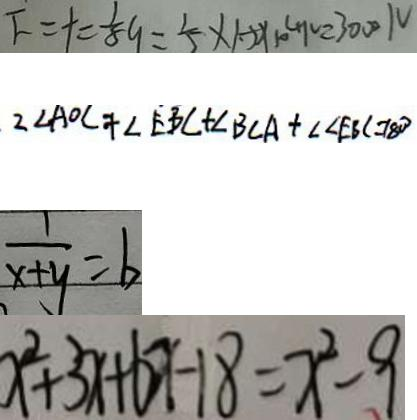Convert formula to latex. <formula><loc_0><loc_0><loc_500><loc_500>F = t = \frac { 1 } { 8 } 9 = \frac { 1 } { 5 } \times 1 . 2 2 \times 1 0 ^ { 4 } N = 3 0 0 N 
 2 \angle A O C + \angle E B C + \angle B C A + \angle \angle E B C = 1 8 0 ^ { \circ } 
 \frac { 1 } { x + y } = b 
 x ^ { 2 } + 3 x + b x - 1 8 = x ^ { 2 } - 9</formula> 